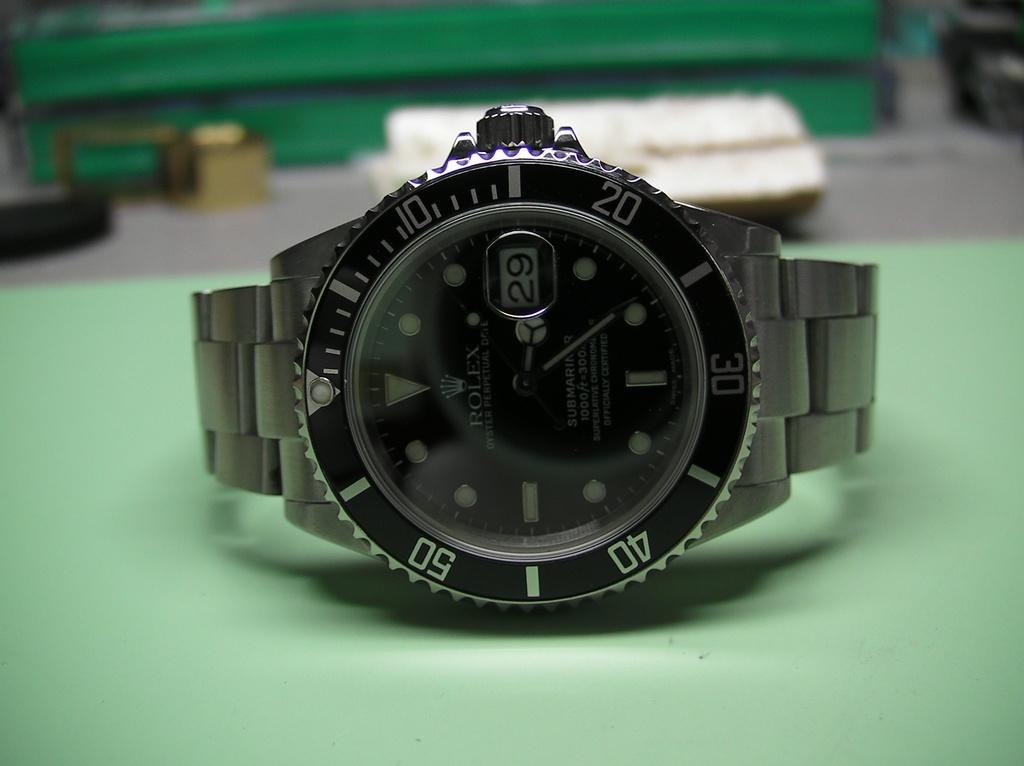<image>
Render a clear and concise summary of the photo. A black watch reads "ROLEX" on the face. 